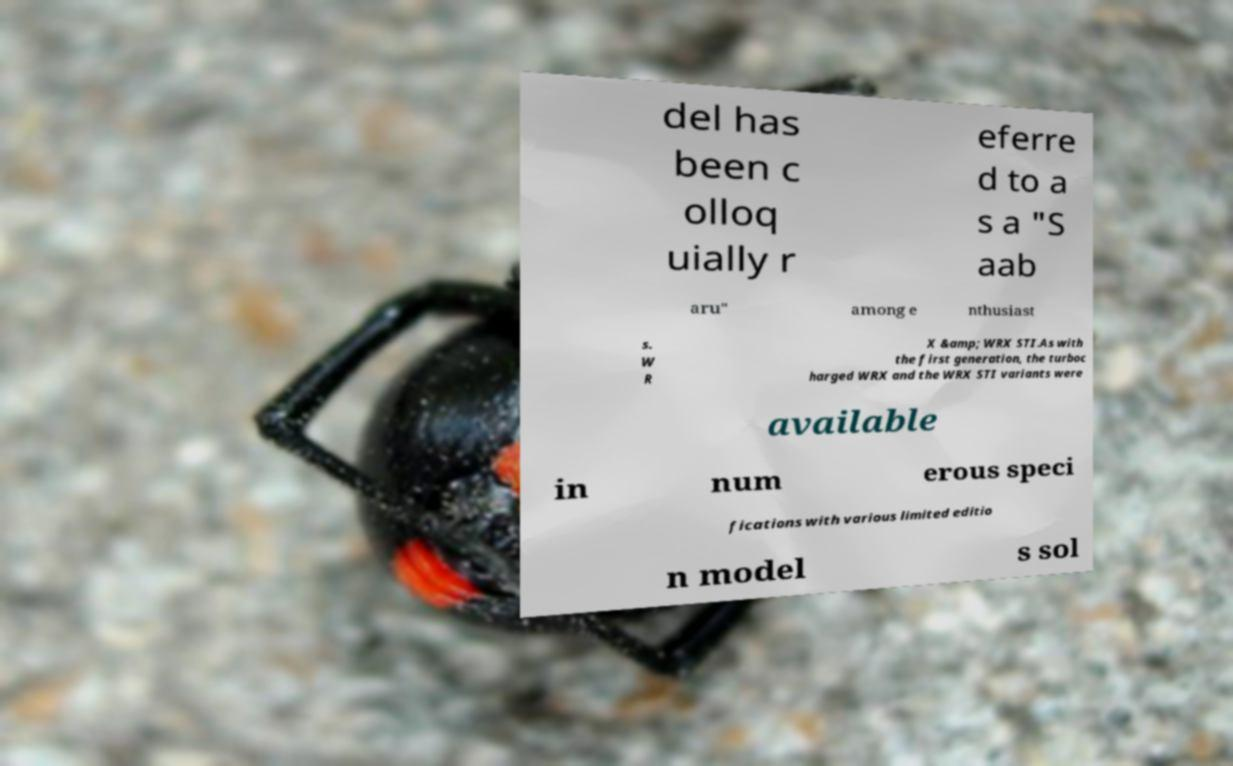I need the written content from this picture converted into text. Can you do that? del has been c olloq uially r eferre d to a s a "S aab aru" among e nthusiast s. W R X &amp; WRX STI.As with the first generation, the turboc harged WRX and the WRX STI variants were available in num erous speci fications with various limited editio n model s sol 